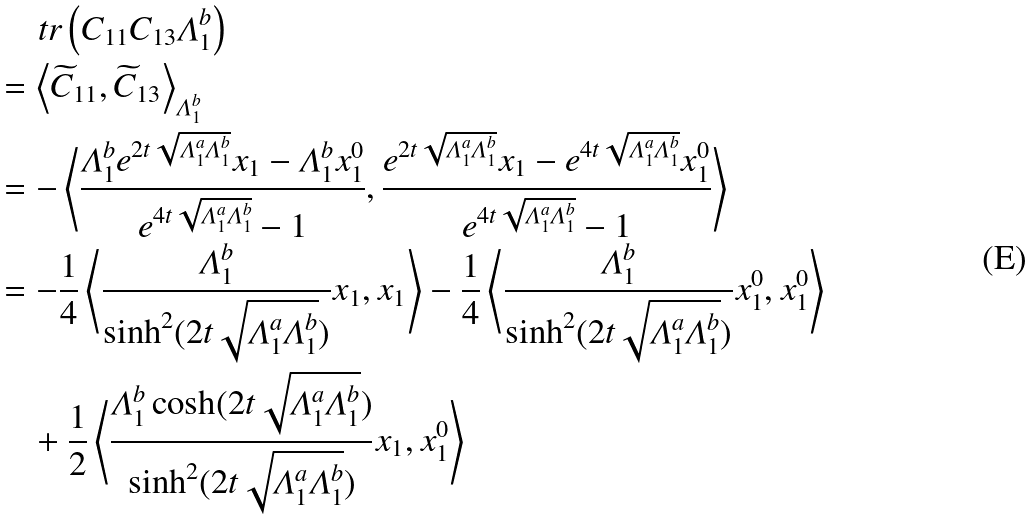<formula> <loc_0><loc_0><loc_500><loc_500>& \quad \ t r \left ( C _ { 1 1 } C _ { 1 3 } \varLambda _ { 1 } ^ { b } \right ) \\ & = \left \langle \widetilde { C } _ { 1 1 } , \widetilde { C } _ { 1 3 } \right \rangle _ { \varLambda _ { 1 } ^ { b } } \\ & = - \left \langle \frac { \varLambda _ { 1 } ^ { b } e ^ { 2 t \sqrt { \varLambda _ { 1 } ^ { a } \varLambda _ { 1 } ^ { b } } } x _ { 1 } - \varLambda _ { 1 } ^ { b } x _ { 1 } ^ { 0 } } { e ^ { 4 t \sqrt { \varLambda _ { 1 } ^ { a } \varLambda _ { 1 } ^ { b } } } - 1 } , \frac { e ^ { 2 t \sqrt { \varLambda _ { 1 } ^ { a } \varLambda _ { 1 } ^ { b } } } x _ { 1 } - e ^ { 4 t \sqrt { \varLambda _ { 1 } ^ { a } \varLambda _ { 1 } ^ { b } } } x _ { 1 } ^ { 0 } } { e ^ { 4 t \sqrt { \varLambda _ { 1 } ^ { a } \varLambda _ { 1 } ^ { b } } } - 1 } \right \rangle \\ & = - \frac { 1 } { 4 } \left \langle \frac { \varLambda _ { 1 } ^ { b } } { \sinh ^ { 2 } ( 2 t \sqrt { \varLambda _ { 1 } ^ { a } \varLambda _ { 1 } ^ { b } } ) } x _ { 1 } , x _ { 1 } \right \rangle - \frac { 1 } { 4 } \left \langle \frac { \varLambda _ { 1 } ^ { b } } { \sinh ^ { 2 } ( 2 t \sqrt { \varLambda _ { 1 } ^ { a } \varLambda _ { 1 } ^ { b } } ) } x _ { 1 } ^ { 0 } , x _ { 1 } ^ { 0 } \right \rangle \\ & \quad + \frac { 1 } { 2 } \left \langle \frac { \varLambda _ { 1 } ^ { b } \cosh ( 2 t \sqrt { \varLambda _ { 1 } ^ { a } \varLambda _ { 1 } ^ { b } } ) } { \sinh ^ { 2 } ( 2 t \sqrt { \varLambda _ { 1 } ^ { a } \varLambda _ { 1 } ^ { b } } ) } x _ { 1 } , x _ { 1 } ^ { 0 } \right \rangle</formula> 